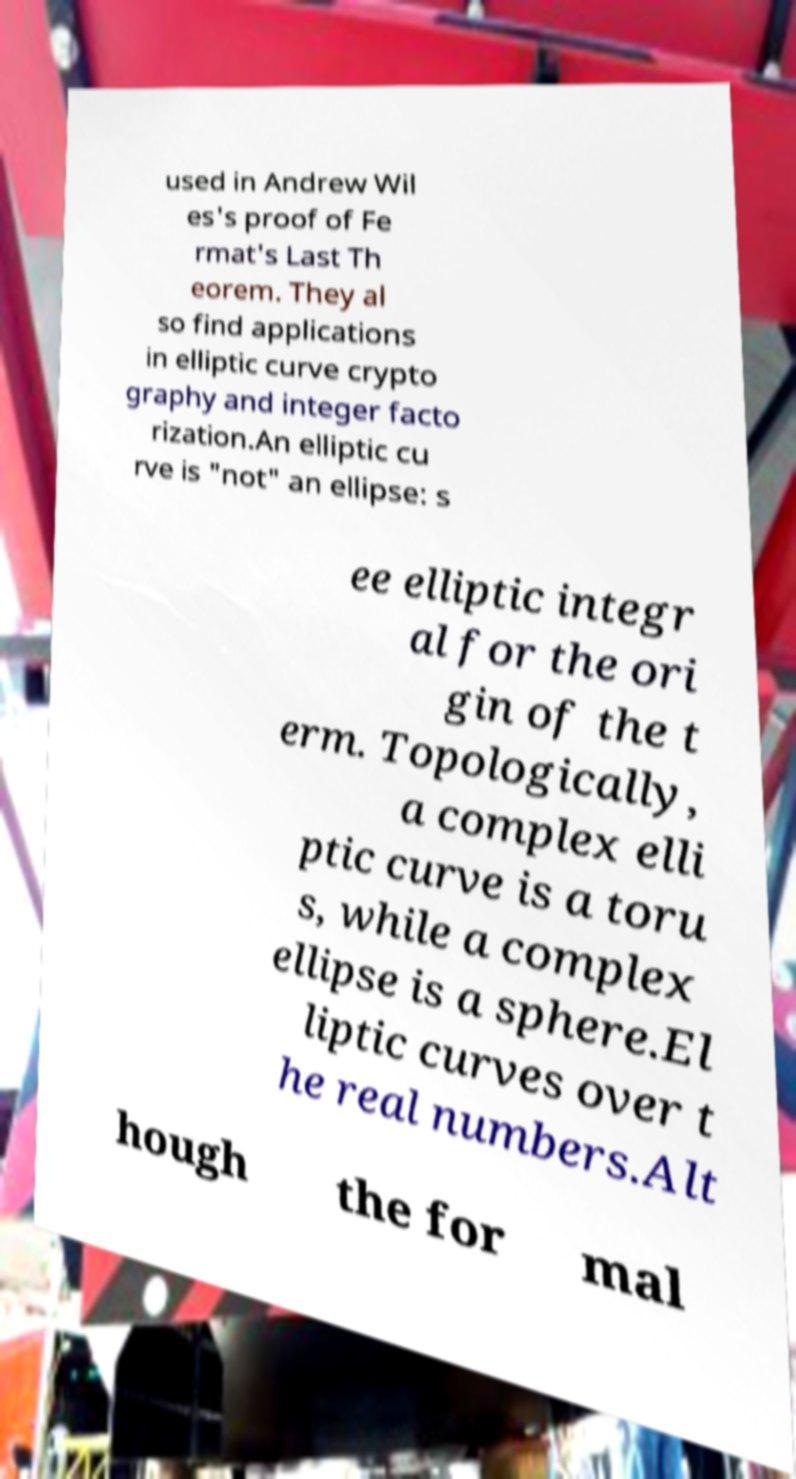I need the written content from this picture converted into text. Can you do that? used in Andrew Wil es's proof of Fe rmat's Last Th eorem. They al so find applications in elliptic curve crypto graphy and integer facto rization.An elliptic cu rve is "not" an ellipse: s ee elliptic integr al for the ori gin of the t erm. Topologically, a complex elli ptic curve is a toru s, while a complex ellipse is a sphere.El liptic curves over t he real numbers.Alt hough the for mal 